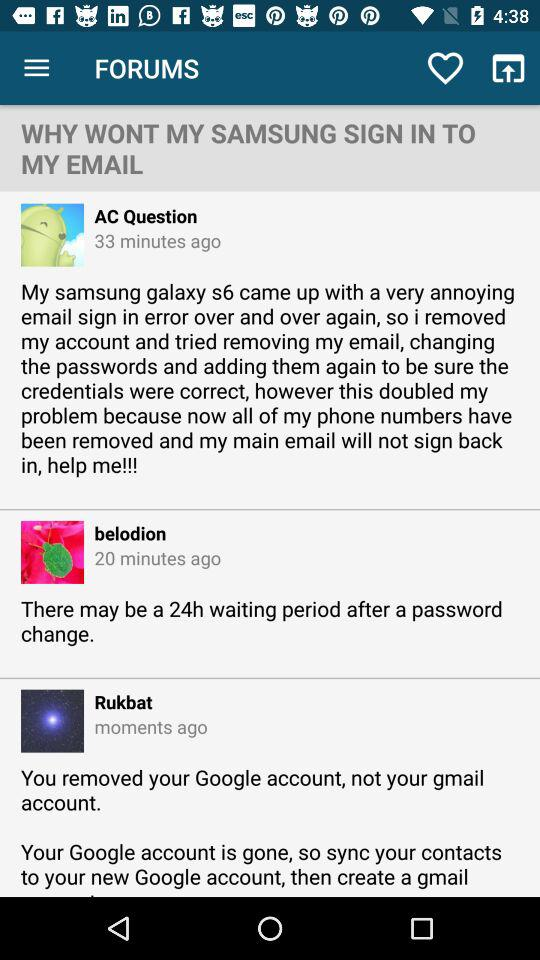How many minutes ago was the post posted by Belodion? The post was posted by Belodion 20 minutes ago. 